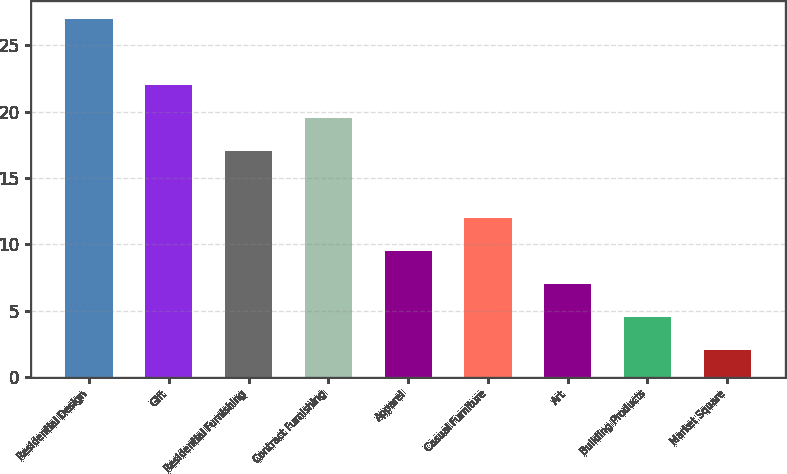<chart> <loc_0><loc_0><loc_500><loc_500><bar_chart><fcel>Residential Design<fcel>Gift<fcel>Residential Furnishing<fcel>Contract Furnishing<fcel>Apparel<fcel>Casual Furniture<fcel>Art<fcel>Building Products<fcel>Market Square<nl><fcel>27<fcel>22<fcel>17<fcel>19.5<fcel>9.5<fcel>12<fcel>7<fcel>4.5<fcel>2<nl></chart> 